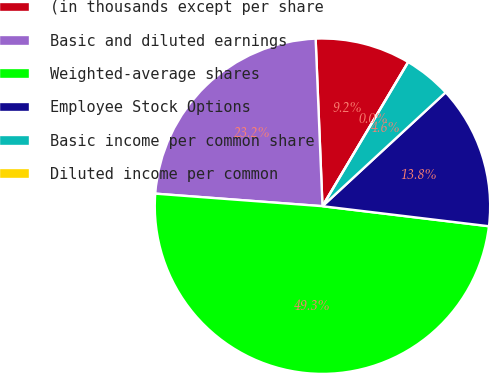<chart> <loc_0><loc_0><loc_500><loc_500><pie_chart><fcel>(in thousands except per share<fcel>Basic and diluted earnings<fcel>Weighted-average shares<fcel>Employee Stock Options<fcel>Basic income per common share<fcel>Diluted income per common<nl><fcel>9.19%<fcel>23.16%<fcel>49.29%<fcel>13.78%<fcel>4.59%<fcel>0.0%<nl></chart> 